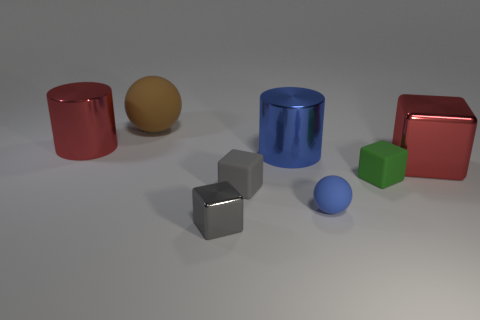Which objects in the image could logically be grouped together based on their attributes? If we group the objects by shape, the two cylinders (one red, one cyan) would form a group, as would the two cubes (one silver, one green). Similarly, the two spheres (one small and blue, one large and yellow) can be grouped together. Considering color, the red cylinder and red cuboid complement each other, as do the silver cube and cyan cylinder in terms of their reflective surfaces. Each grouping accentuates the similarities in shape or color among the objects. 